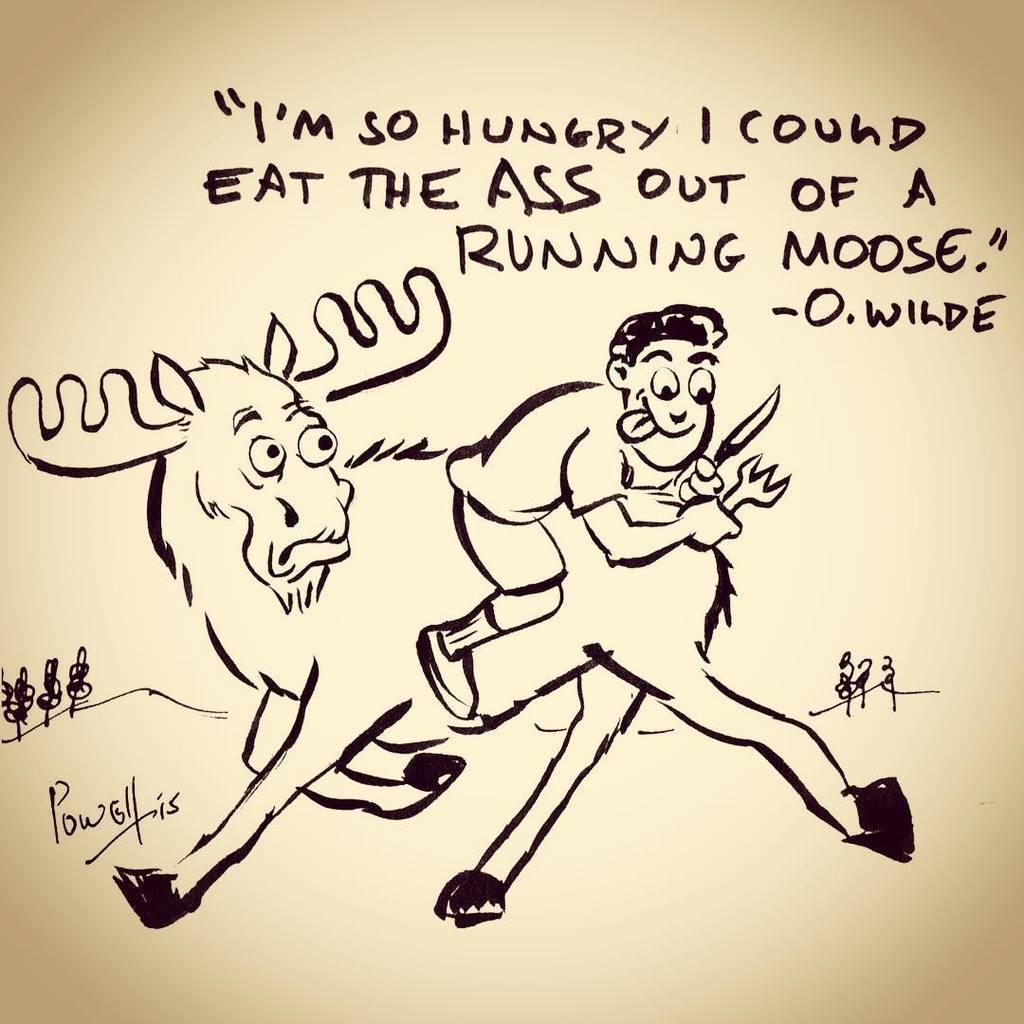Can you describe this image briefly? In this image we can see drawing of a donkey and man with some text written on it. 